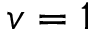Convert formula to latex. <formula><loc_0><loc_0><loc_500><loc_500>v = 1</formula> 